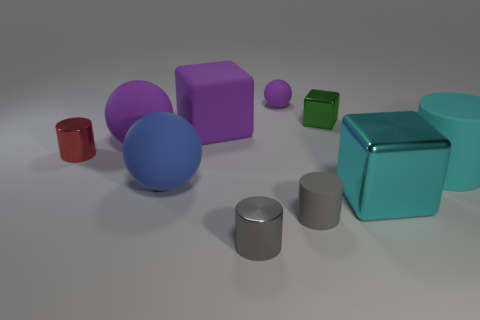Subtract all small gray rubber cylinders. How many cylinders are left? 3 Subtract all purple spheres. How many spheres are left? 1 Subtract 2 cylinders. How many cylinders are left? 2 Add 1 big rubber blocks. How many big rubber blocks exist? 2 Subtract 1 blue balls. How many objects are left? 9 Subtract all blocks. How many objects are left? 7 Subtract all blue spheres. Subtract all green cubes. How many spheres are left? 2 Subtract all cyan spheres. How many red cubes are left? 0 Subtract all purple blocks. Subtract all matte blocks. How many objects are left? 8 Add 5 large metal objects. How many large metal objects are left? 6 